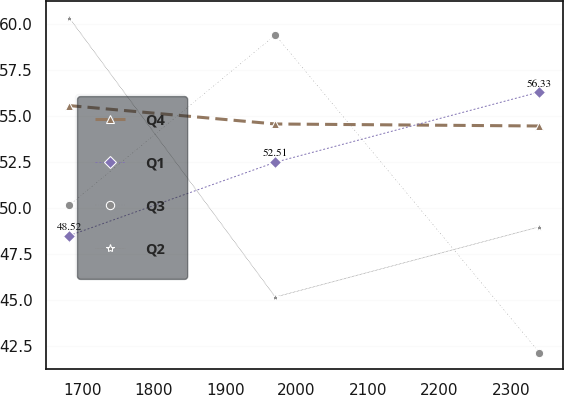Convert chart. <chart><loc_0><loc_0><loc_500><loc_500><line_chart><ecel><fcel>Q4<fcel>Q1<fcel>Q3<fcel>Q2<nl><fcel>1681.67<fcel>55.59<fcel>48.52<fcel>50.17<fcel>60.36<nl><fcel>1970.19<fcel>54.59<fcel>52.51<fcel>59.43<fcel>45.18<nl><fcel>2340.03<fcel>54.48<fcel>56.33<fcel>42.16<fcel>49<nl></chart> 